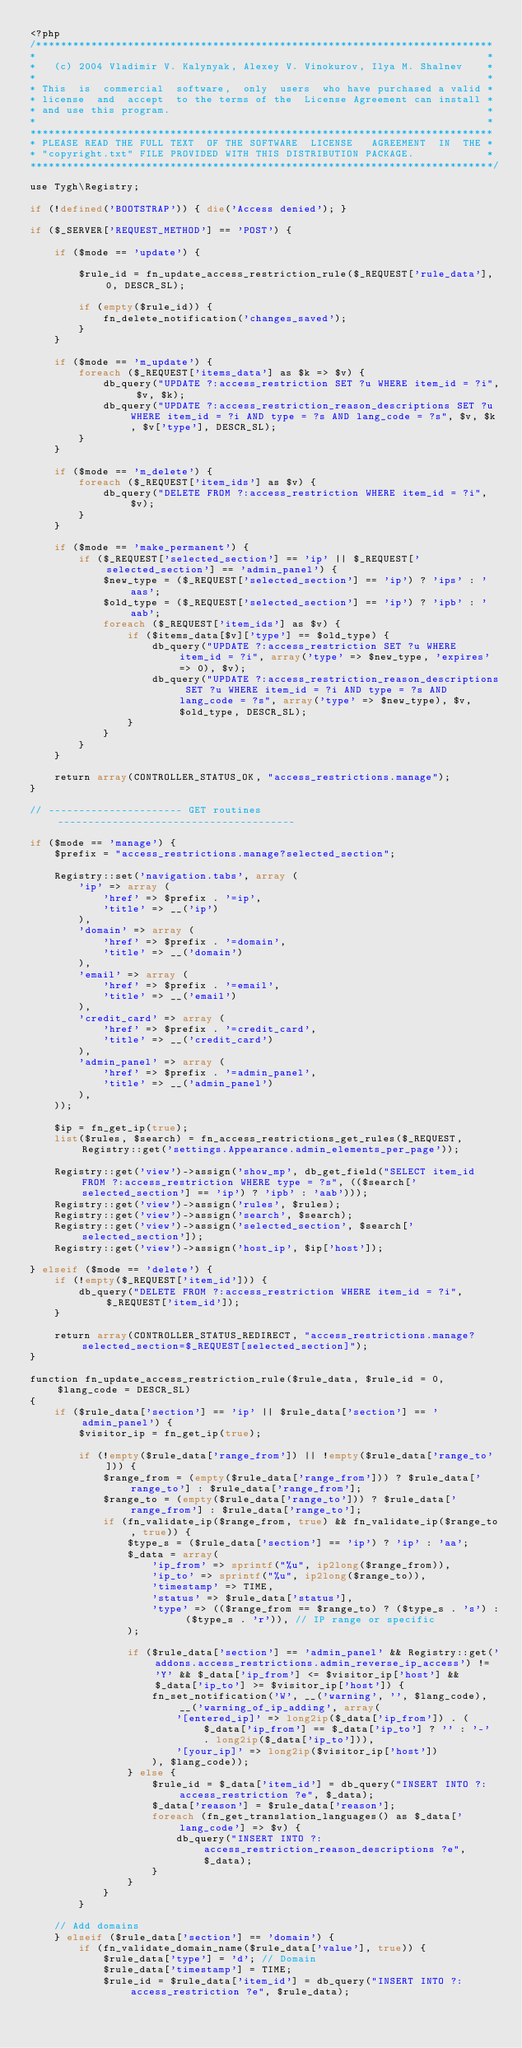Convert code to text. <code><loc_0><loc_0><loc_500><loc_500><_PHP_><?php
/***************************************************************************
*                                                                          *
*   (c) 2004 Vladimir V. Kalynyak, Alexey V. Vinokurov, Ilya M. Shalnev    *
*                                                                          *
* This  is  commercial  software,  only  users  who have purchased a valid *
* license  and  accept  to the terms of the  License Agreement can install *
* and use this program.                                                    *
*                                                                          *
****************************************************************************
* PLEASE READ THE FULL TEXT  OF THE SOFTWARE  LICENSE   AGREEMENT  IN  THE *
* "copyright.txt" FILE PROVIDED WITH THIS DISTRIBUTION PACKAGE.            *
****************************************************************************/

use Tygh\Registry;

if (!defined('BOOTSTRAP')) { die('Access denied'); }

if ($_SERVER['REQUEST_METHOD'] == 'POST') {

    if ($mode == 'update') {

        $rule_id = fn_update_access_restriction_rule($_REQUEST['rule_data'], 0, DESCR_SL);

        if (empty($rule_id)) {
            fn_delete_notification('changes_saved');
        }
    }

    if ($mode == 'm_update') {
        foreach ($_REQUEST['items_data'] as $k => $v) {
            db_query("UPDATE ?:access_restriction SET ?u WHERE item_id = ?i", $v, $k);
            db_query("UPDATE ?:access_restriction_reason_descriptions SET ?u WHERE item_id = ?i AND type = ?s AND lang_code = ?s", $v, $k, $v['type'], DESCR_SL);
        }
    }

    if ($mode == 'm_delete') {
        foreach ($_REQUEST['item_ids'] as $v) {
            db_query("DELETE FROM ?:access_restriction WHERE item_id = ?i", $v);
        }
    }

    if ($mode == 'make_permanent') {
        if ($_REQUEST['selected_section'] == 'ip' || $_REQUEST['selected_section'] == 'admin_panel') {
            $new_type = ($_REQUEST['selected_section'] == 'ip') ? 'ips' : 'aas';
            $old_type = ($_REQUEST['selected_section'] == 'ip') ? 'ipb' : 'aab';
            foreach ($_REQUEST['item_ids'] as $v) {
                if ($items_data[$v]['type'] == $old_type) {
                    db_query("UPDATE ?:access_restriction SET ?u WHERE item_id = ?i", array('type' => $new_type, 'expires' => 0), $v);
                    db_query("UPDATE ?:access_restriction_reason_descriptions SET ?u WHERE item_id = ?i AND type = ?s AND lang_code = ?s", array('type' => $new_type), $v, $old_type, DESCR_SL);
                }
            }
        }
    }

    return array(CONTROLLER_STATUS_OK, "access_restrictions.manage");
}

// ---------------------- GET routines ---------------------------------------

if ($mode == 'manage') {
    $prefix = "access_restrictions.manage?selected_section";

    Registry::set('navigation.tabs', array (
        'ip' => array (
            'href' => $prefix . '=ip',
            'title' => __('ip')
        ),
        'domain' => array (
            'href' => $prefix . '=domain',
            'title' => __('domain')
        ),
        'email' => array (
            'href' => $prefix . '=email',
            'title' => __('email')
        ),
        'credit_card' => array (
            'href' => $prefix . '=credit_card',
            'title' => __('credit_card')
        ),
        'admin_panel' => array (
            'href' => $prefix . '=admin_panel',
            'title' => __('admin_panel')
        ),
    ));

    $ip = fn_get_ip(true);
    list($rules, $search) = fn_access_restrictions_get_rules($_REQUEST, Registry::get('settings.Appearance.admin_elements_per_page'));

    Registry::get('view')->assign('show_mp', db_get_field("SELECT item_id FROM ?:access_restriction WHERE type = ?s", (($search['selected_section'] == 'ip') ? 'ipb' : 'aab')));
    Registry::get('view')->assign('rules', $rules);
    Registry::get('view')->assign('search', $search);
    Registry::get('view')->assign('selected_section', $search['selected_section']);
    Registry::get('view')->assign('host_ip', $ip['host']);

} elseif ($mode == 'delete') {
    if (!empty($_REQUEST['item_id'])) {
        db_query("DELETE FROM ?:access_restriction WHERE item_id = ?i", $_REQUEST['item_id']);
    }

    return array(CONTROLLER_STATUS_REDIRECT, "access_restrictions.manage?selected_section=$_REQUEST[selected_section]");
}

function fn_update_access_restriction_rule($rule_data, $rule_id = 0, $lang_code = DESCR_SL)
{
    if ($rule_data['section'] == 'ip' || $rule_data['section'] == 'admin_panel') {
        $visitor_ip = fn_get_ip(true);

        if (!empty($rule_data['range_from']) || !empty($rule_data['range_to'])) {
            $range_from = (empty($rule_data['range_from'])) ? $rule_data['range_to'] : $rule_data['range_from'];
            $range_to = (empty($rule_data['range_to'])) ? $rule_data['range_from'] : $rule_data['range_to'];
            if (fn_validate_ip($range_from, true) && fn_validate_ip($range_to, true)) {
                $type_s = ($rule_data['section'] == 'ip') ? 'ip' : 'aa';
                $_data = array(
                    'ip_from' => sprintf("%u", ip2long($range_from)),
                    'ip_to' => sprintf("%u", ip2long($range_to)),
                    'timestamp' => TIME,
                    'status' => $rule_data['status'],
                    'type' => (($range_from == $range_to) ? ($type_s . 's') : ($type_s . 'r')), // IP range or specific
                );

                if ($rule_data['section'] == 'admin_panel' && Registry::get('addons.access_restrictions.admin_reverse_ip_access') != 'Y' && $_data['ip_from'] <= $visitor_ip['host'] && $_data['ip_to'] >= $visitor_ip['host']) {
                    fn_set_notification('W', __('warning', '', $lang_code), __('warning_of_ip_adding', array(
                        '[entered_ip]' => long2ip($_data['ip_from']) . ($_data['ip_from'] == $_data['ip_to'] ? '' : '-' . long2ip($_data['ip_to'])),
                        '[your_ip]' => long2ip($visitor_ip['host'])
                    ), $lang_code));
                } else {
                    $rule_id = $_data['item_id'] = db_query("INSERT INTO ?:access_restriction ?e", $_data);
                    $_data['reason'] = $rule_data['reason'];
                    foreach (fn_get_translation_languages() as $_data['lang_code'] => $v) {
                        db_query("INSERT INTO ?:access_restriction_reason_descriptions ?e", $_data);
                    }
                }
            }
        }

    // Add domains
    } elseif ($rule_data['section'] == 'domain') {
        if (fn_validate_domain_name($rule_data['value'], true)) {
            $rule_data['type'] = 'd'; // Domain
            $rule_data['timestamp'] = TIME;
            $rule_id = $rule_data['item_id'] = db_query("INSERT INTO ?:access_restriction ?e", $rule_data);
</code> 